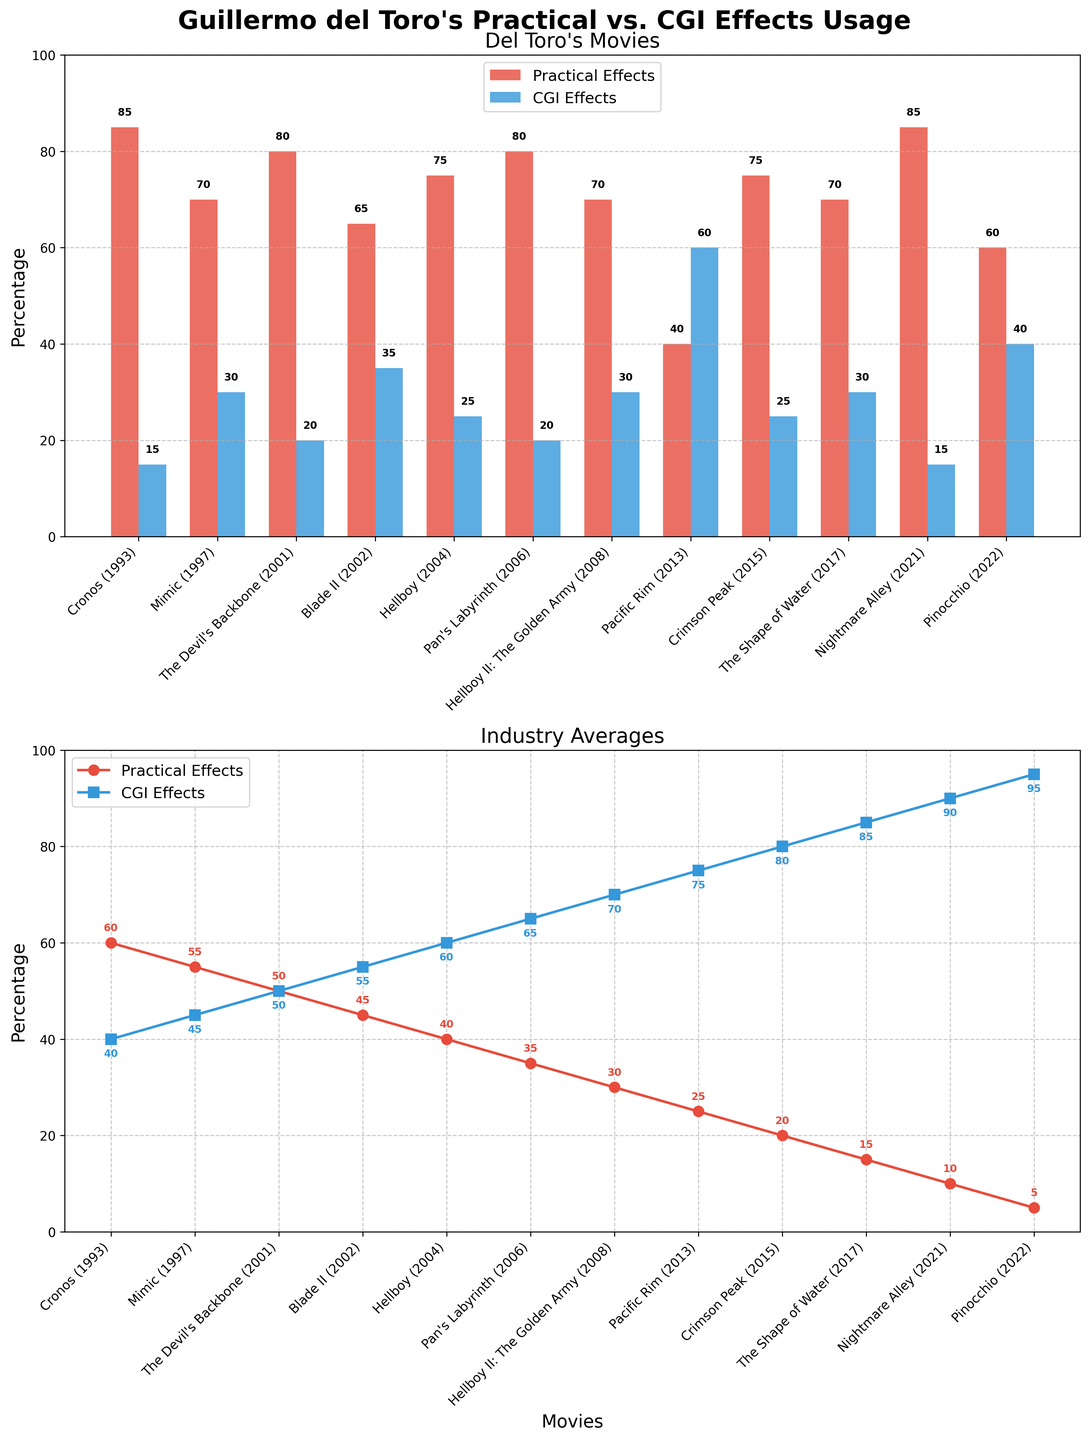What percentage of practical effects did Guillermo del Toro use in "Cronos (1993)"? Look at the bar corresponding to practical effects in "Cronos (1993)" in the first subplot. The bar indicates a value of 85%.
Answer: 85% Which del Toro movie uses the most CGI effects? In the first subplot, compare the heights of the blue bars representing CGI effects for each movie. "Pacific Rim (2013)" has the tallest blue bar, indicating the highest CGI usage at 60%.
Answer: Pacific Rim (2013) How does the industry average of practical effects for "Pan's Labyrinth (2006)" compare to del Toro's usage in the same movie? In the second subplot, locate "Pan's Labyrinth (2006)" and observe the red line's height for practical effects, which is 35%. Compare this with the red bar in the first subplot, which is 80%. Thus, del Toro used significantly more practical effects than the industry average.
Answer: Del Toro used 80%, Industry used 35% Calculate the average percentage of CGI effects across all del Toro movies. Sum the CGI percentages for all movies in the first subplot: (15 + 30 + 20 + 35 + 25 + 20 + 30 + 60 + 25 + 30 + 15 + 40) = 345. Divide by the number of movies (12): 345 / 12 ≈ 28.75%.
Answer: 28.75% Is there a trend in del Toro's usage of practical effects over time? Examine the heights of the red bars in the first subplot across the timeline from "Cronos (1993)" to "Pinocchio (2022)". Notice that while all values are high, recent movies show a varied trend, with no clear increase or decrease.
Answer: No clear trend Which movie has the greatest difference between del Toro's and the industry's practical effect usage? Find the movie with the largest gap between the red bar in the first subplot and the red point in the second subplot. "Nightmare Alley (2021)" shows del Toro at 85% and the industry at 10%, a difference of 75%.
Answer: Nightmare Alley (2021) What is the overall industry trend for CGI effects from "Cronos (1993)" to "Pinocchio (2022)"? Observe the blue line in the second subplot representing CGI effects. Notice an increasing trend, reaching up to 95% in recent movies.
Answer: Increasing trend Compare the practical effects usage between "Hellboy (2004)" and "Hellboy II: The Golden Army (2008)" for del Toro and the industry. In the first subplot, "Hellboy (2004)" shows 75% practical effects versus 70% in "Hellboy II (2008)". In the second subplot, the industry shows 40% in 2004 and 30% in 2008.
Answer: Del Toro: 75% vs 70%, Industry: 40% vs 30% How does the usage of CGI effects in "Pacific Rim (2013)" compare between del Toro and the industry? In "Pacific Rim (2013)", the first subplot shows del Toro's CGI usage at 60%. The second subplot shows the industry average at 75%.
Answer: Del Toro 60%, Industry 75% What is the percentage of practical effects in "The Shape of Water (2017)" compared to the industry average? Look for the red bar in the first subplot for "The Shape of Water (2017)" which shows 70%. The red point in the second subplot shows the industry average at 15%.
Answer: Del Toro 70%, Industry 15% 